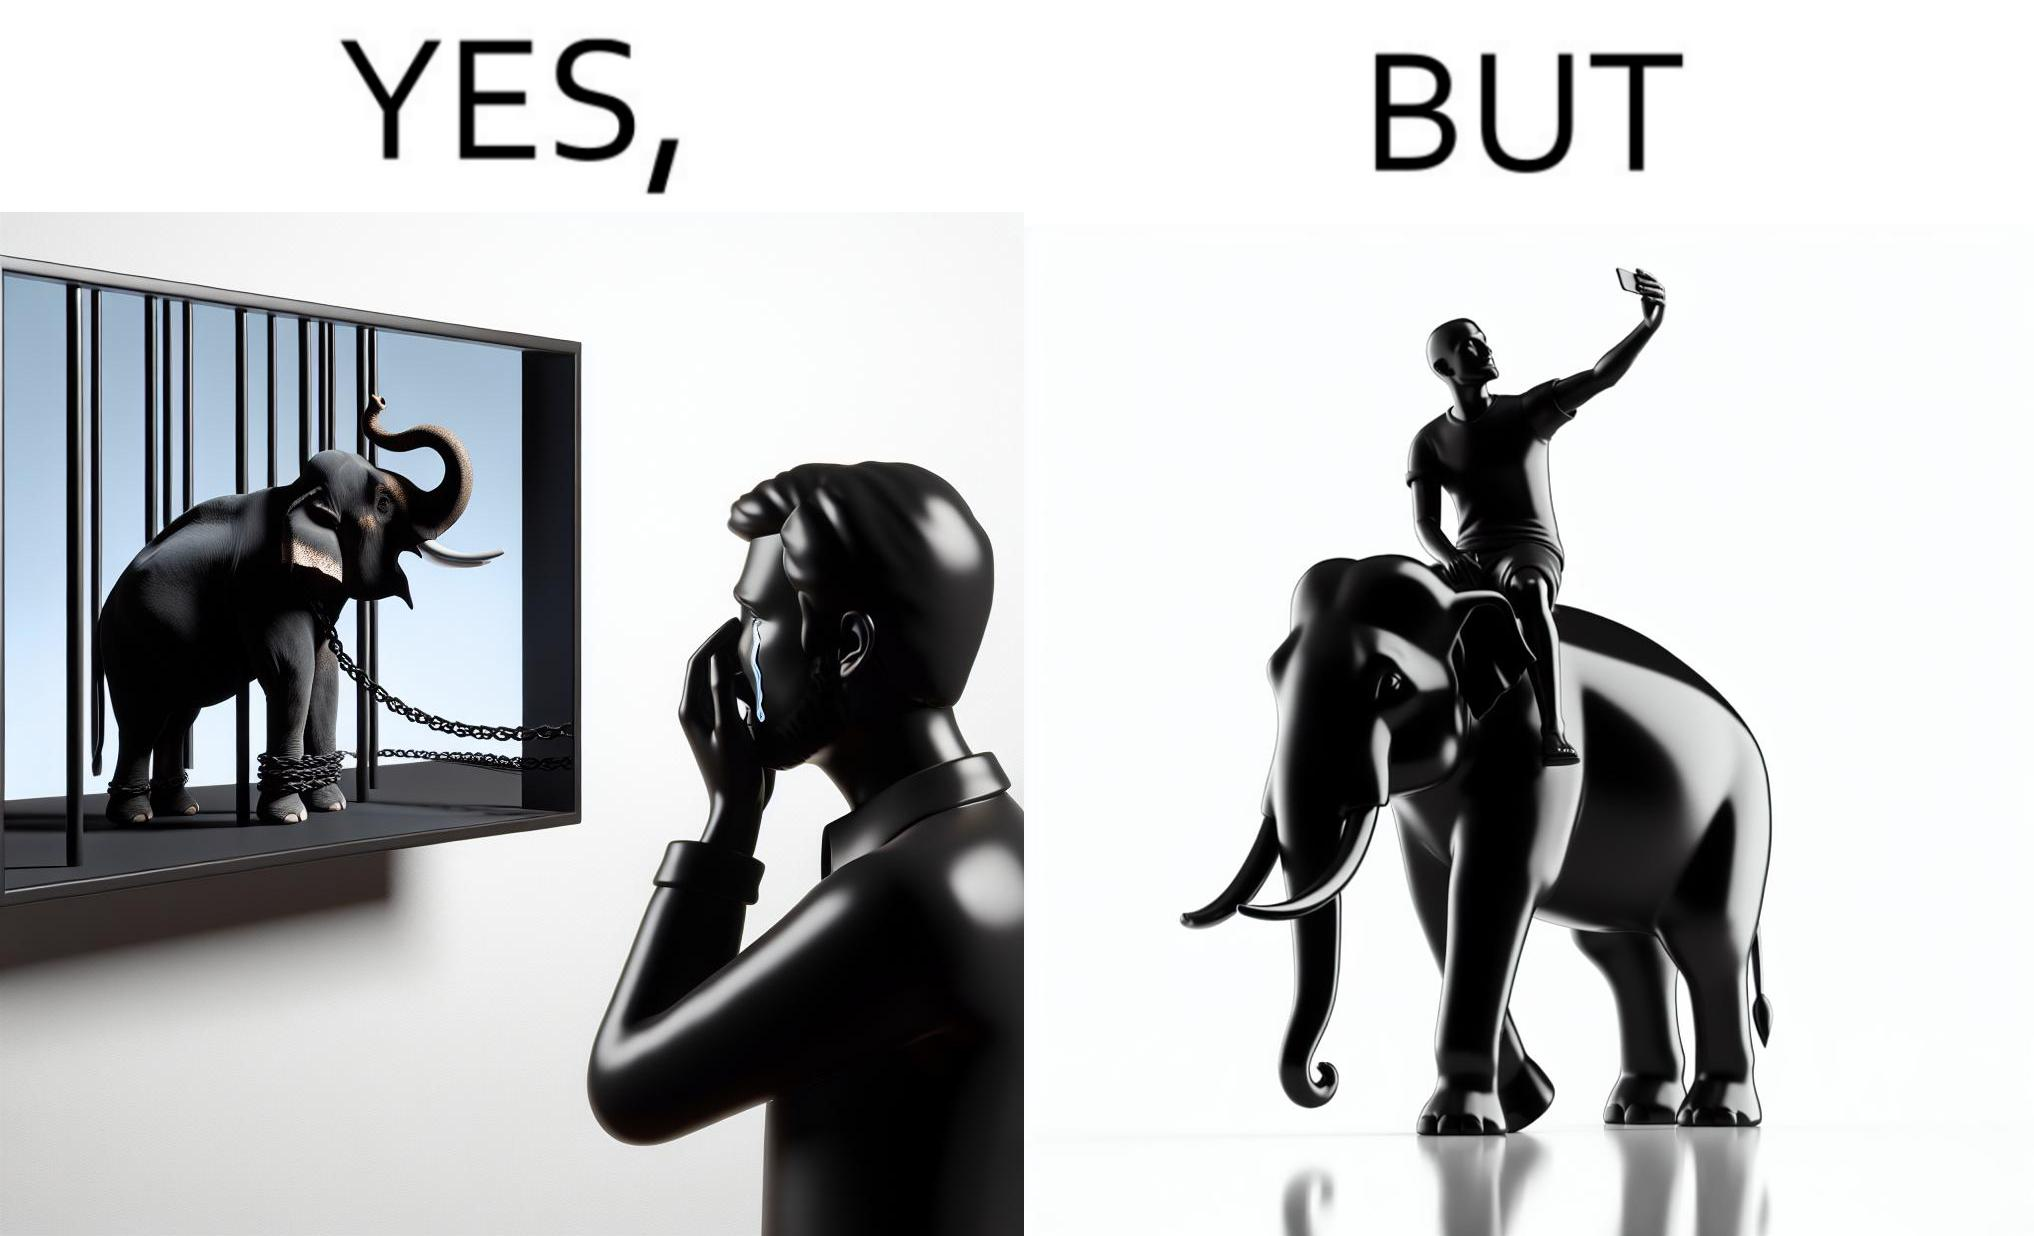Explain the humor or irony in this image. The image is ironic, because the people who get sentimental over imprisoned animal while watching TV shows often feel okay when using animals for labor 